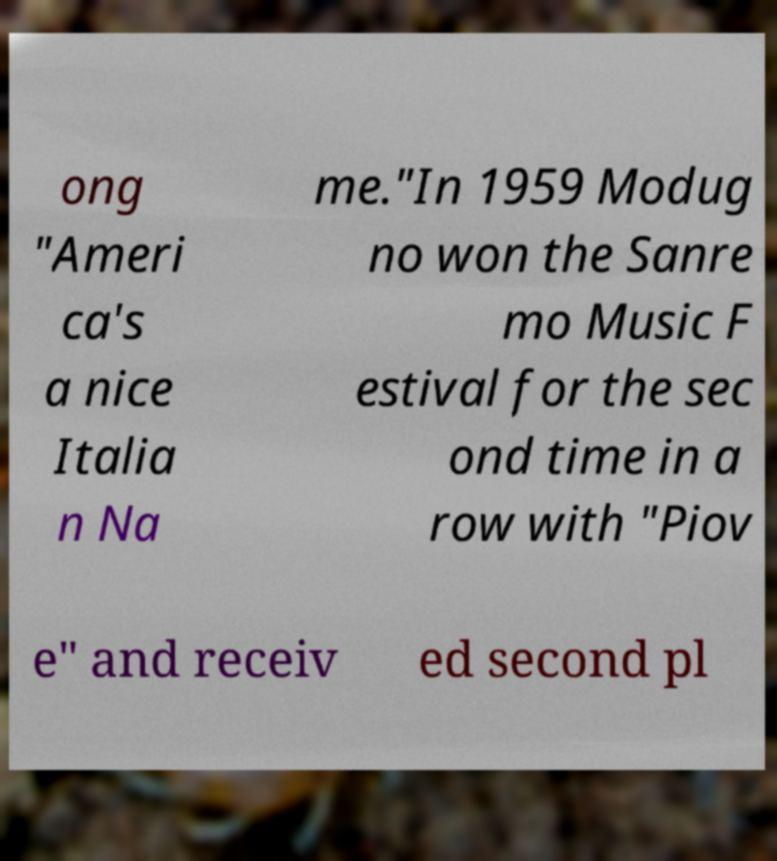For documentation purposes, I need the text within this image transcribed. Could you provide that? ong "Ameri ca's a nice Italia n Na me."In 1959 Modug no won the Sanre mo Music F estival for the sec ond time in a row with "Piov e" and receiv ed second pl 